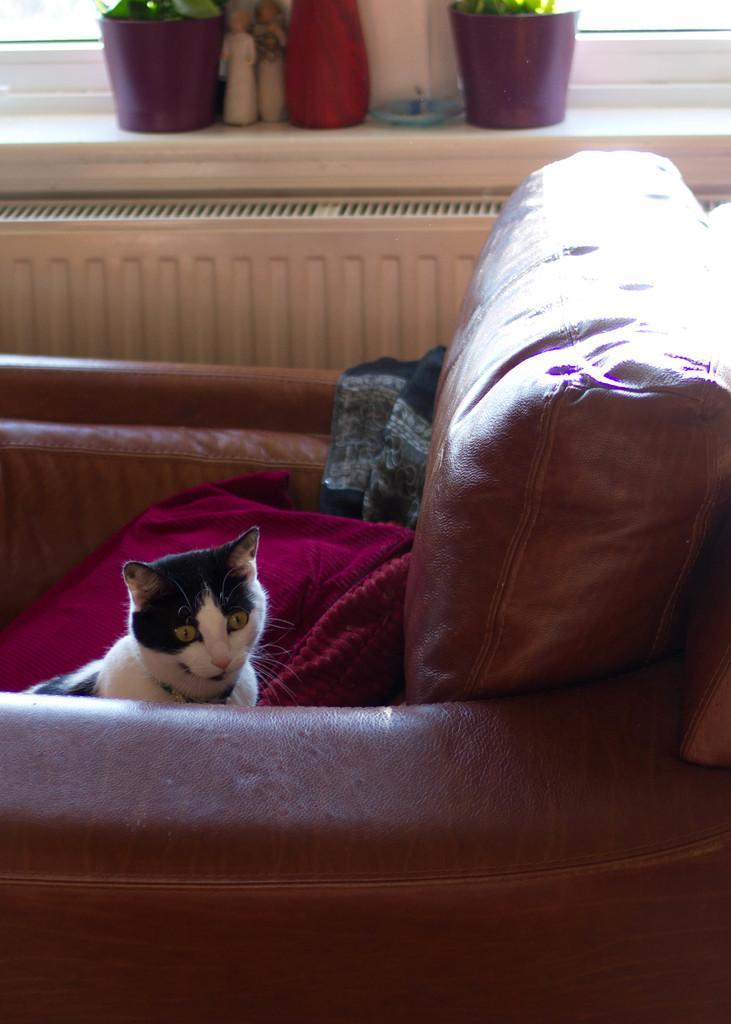Can you describe this image briefly? In this image I can see a couch which is brown in color and on the couch I can see a red colored cushion and a cat which is white and black in color. In the background I can see the window, few flower pots with plants in them and few other objects. 